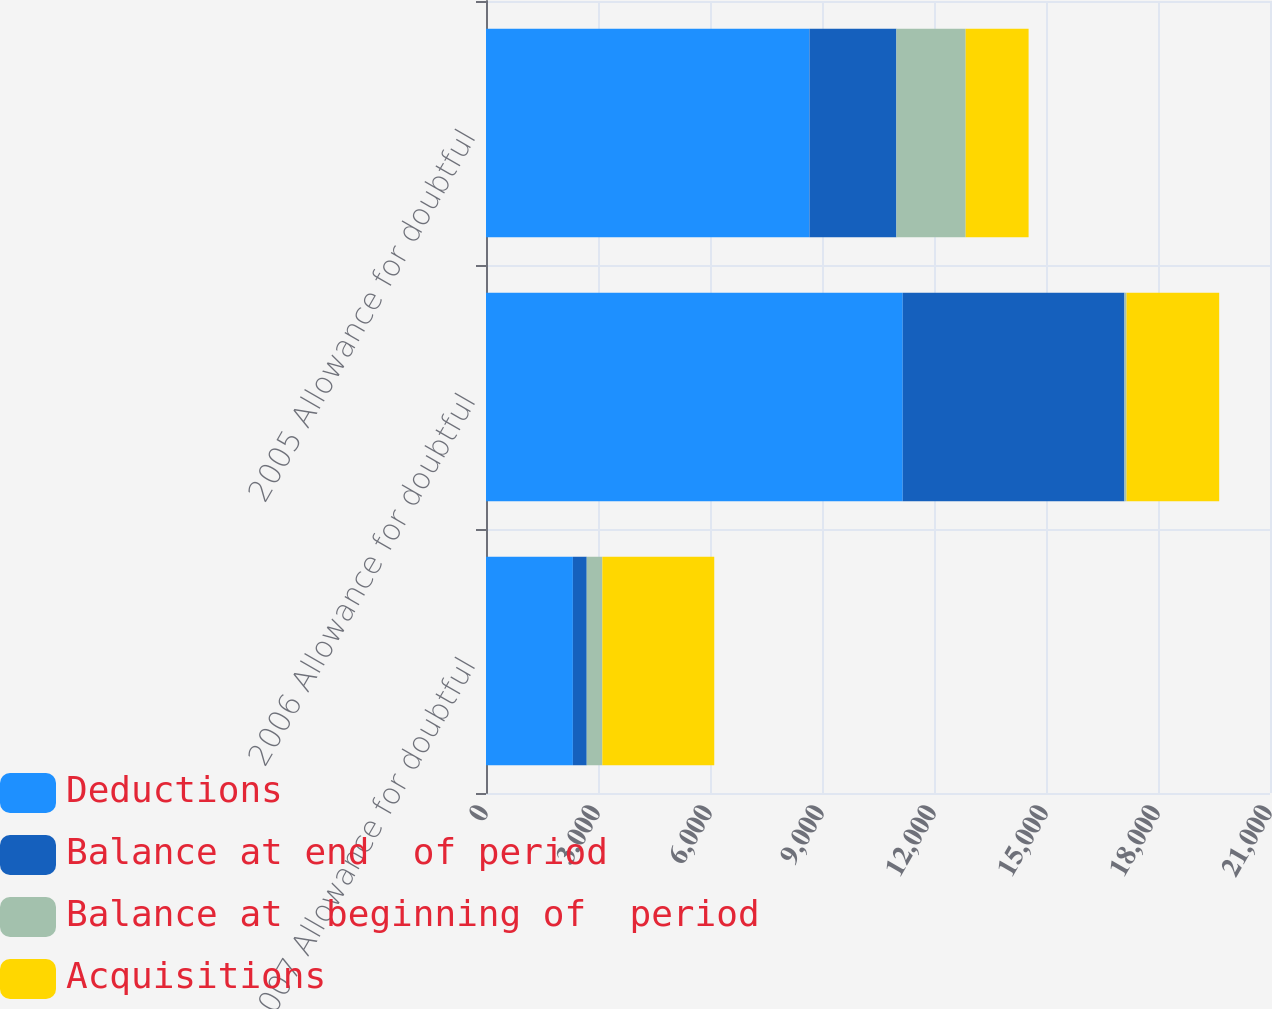<chart> <loc_0><loc_0><loc_500><loc_500><stacked_bar_chart><ecel><fcel>2007 Allowance for doubtful<fcel>2006 Allowance for doubtful<fcel>2005 Allowance for doubtful<nl><fcel>Deductions<fcel>2327<fcel>11162<fcel>8666<nl><fcel>Balance at end  of period<fcel>371<fcel>5939<fcel>2327<nl><fcel>Balance at  beginning of  period<fcel>418<fcel>57<fcel>1855<nl><fcel>Acquisitions<fcel>2998<fcel>2481<fcel>1686<nl></chart> 